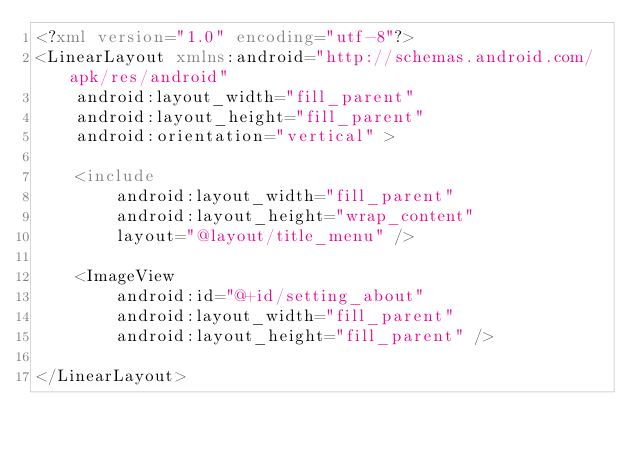<code> <loc_0><loc_0><loc_500><loc_500><_XML_><?xml version="1.0" encoding="utf-8"?>
<LinearLayout xmlns:android="http://schemas.android.com/apk/res/android"
    android:layout_width="fill_parent"
    android:layout_height="fill_parent"
    android:orientation="vertical" >

    <include
        android:layout_width="fill_parent"
        android:layout_height="wrap_content"
        layout="@layout/title_menu" />

    <ImageView
        android:id="@+id/setting_about"
        android:layout_width="fill_parent"
        android:layout_height="fill_parent" />

</LinearLayout></code> 